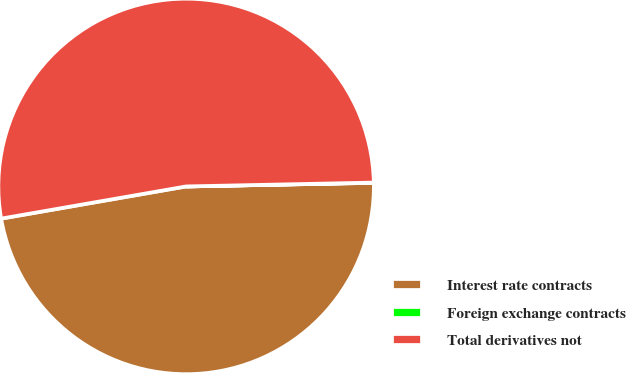Convert chart to OTSL. <chart><loc_0><loc_0><loc_500><loc_500><pie_chart><fcel>Interest rate contracts<fcel>Foreign exchange contracts<fcel>Total derivatives not<nl><fcel>47.56%<fcel>0.02%<fcel>52.41%<nl></chart> 